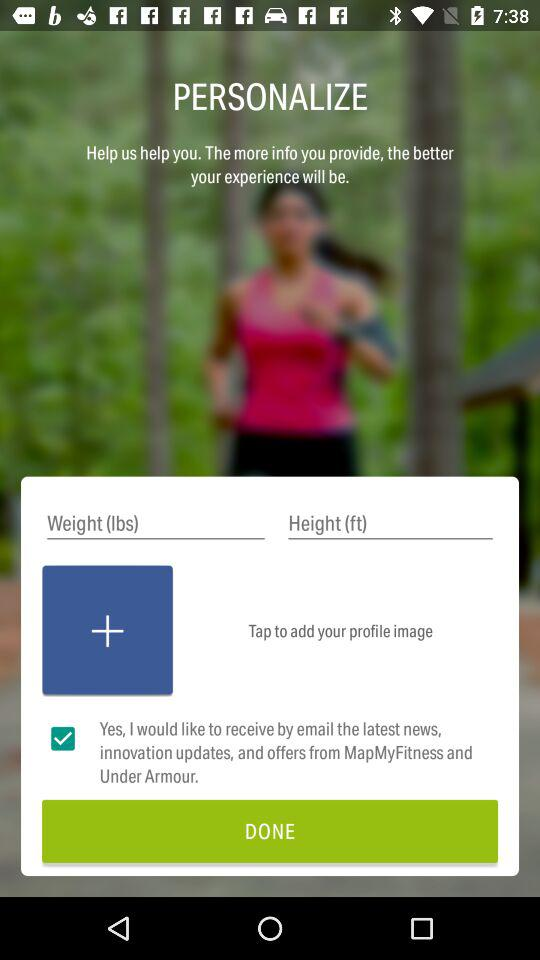How many input fields are there for personal information?
Answer the question using a single word or phrase. 2 